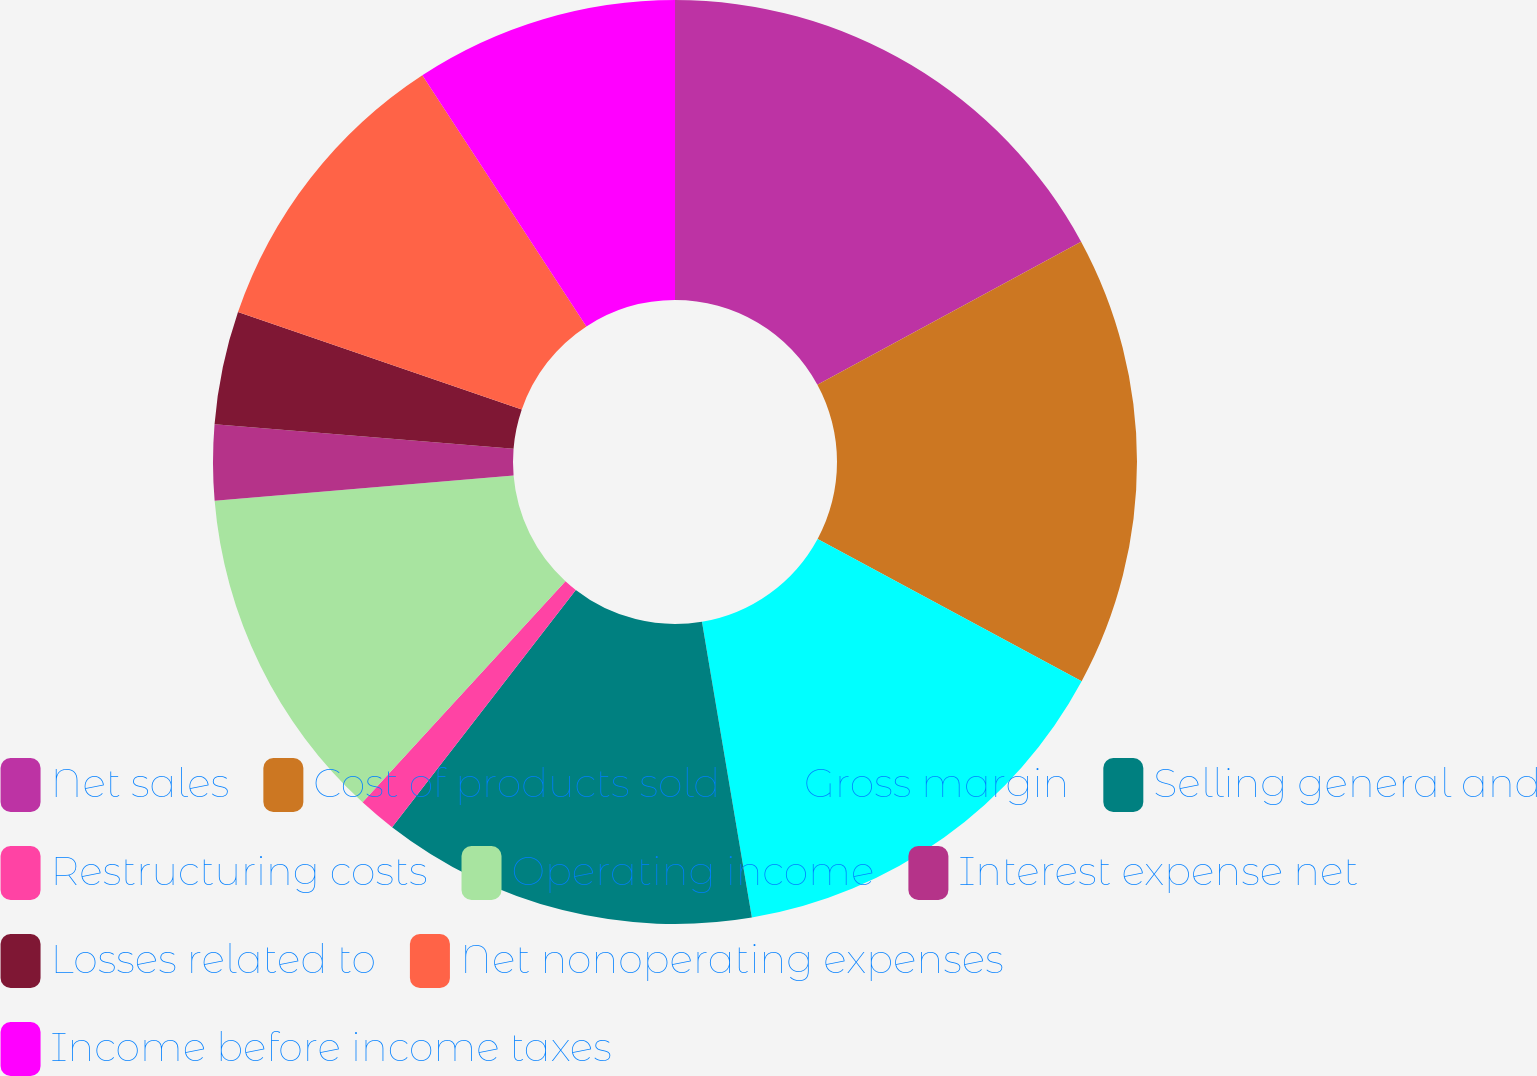Convert chart. <chart><loc_0><loc_0><loc_500><loc_500><pie_chart><fcel>Net sales<fcel>Cost of products sold<fcel>Gross margin<fcel>Selling general and<fcel>Restructuring costs<fcel>Operating income<fcel>Interest expense net<fcel>Losses related to<fcel>Net nonoperating expenses<fcel>Income before income taxes<nl><fcel>17.09%<fcel>15.78%<fcel>14.47%<fcel>13.15%<fcel>1.33%<fcel>11.84%<fcel>2.64%<fcel>3.96%<fcel>10.53%<fcel>9.21%<nl></chart> 